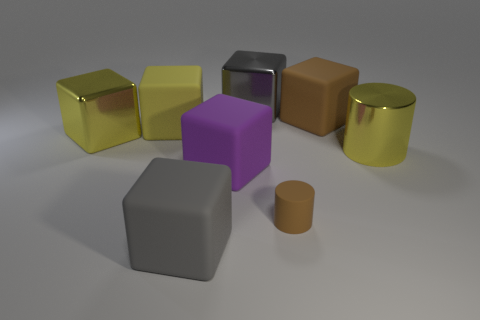Subtract all brown rubber cubes. How many cubes are left? 5 Subtract all purple blocks. How many blocks are left? 5 Subtract all blue cubes. Subtract all cyan spheres. How many cubes are left? 6 Add 1 big things. How many objects exist? 9 Subtract all blocks. How many objects are left? 2 Add 7 large gray blocks. How many large gray blocks exist? 9 Subtract 0 gray balls. How many objects are left? 8 Subtract all big blue rubber cylinders. Subtract all large gray rubber objects. How many objects are left? 7 Add 5 yellow cylinders. How many yellow cylinders are left? 6 